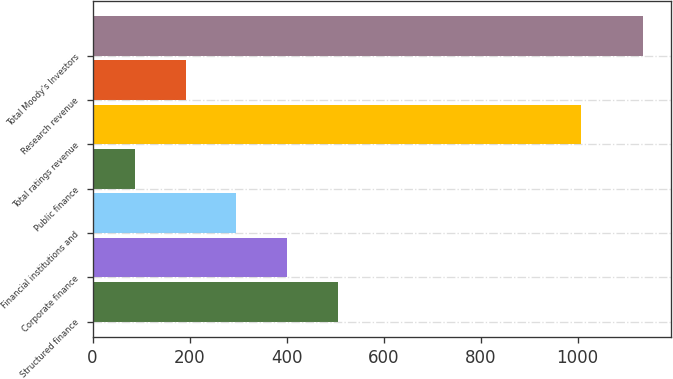Convert chart to OTSL. <chart><loc_0><loc_0><loc_500><loc_500><bar_chart><fcel>Structured finance<fcel>Corporate finance<fcel>Financial institutions and<fcel>Public finance<fcel>Total ratings revenue<fcel>Research revenue<fcel>Total Moody's Investors<nl><fcel>506.2<fcel>401.45<fcel>296.7<fcel>87.2<fcel>1007.8<fcel>191.95<fcel>1134.7<nl></chart> 